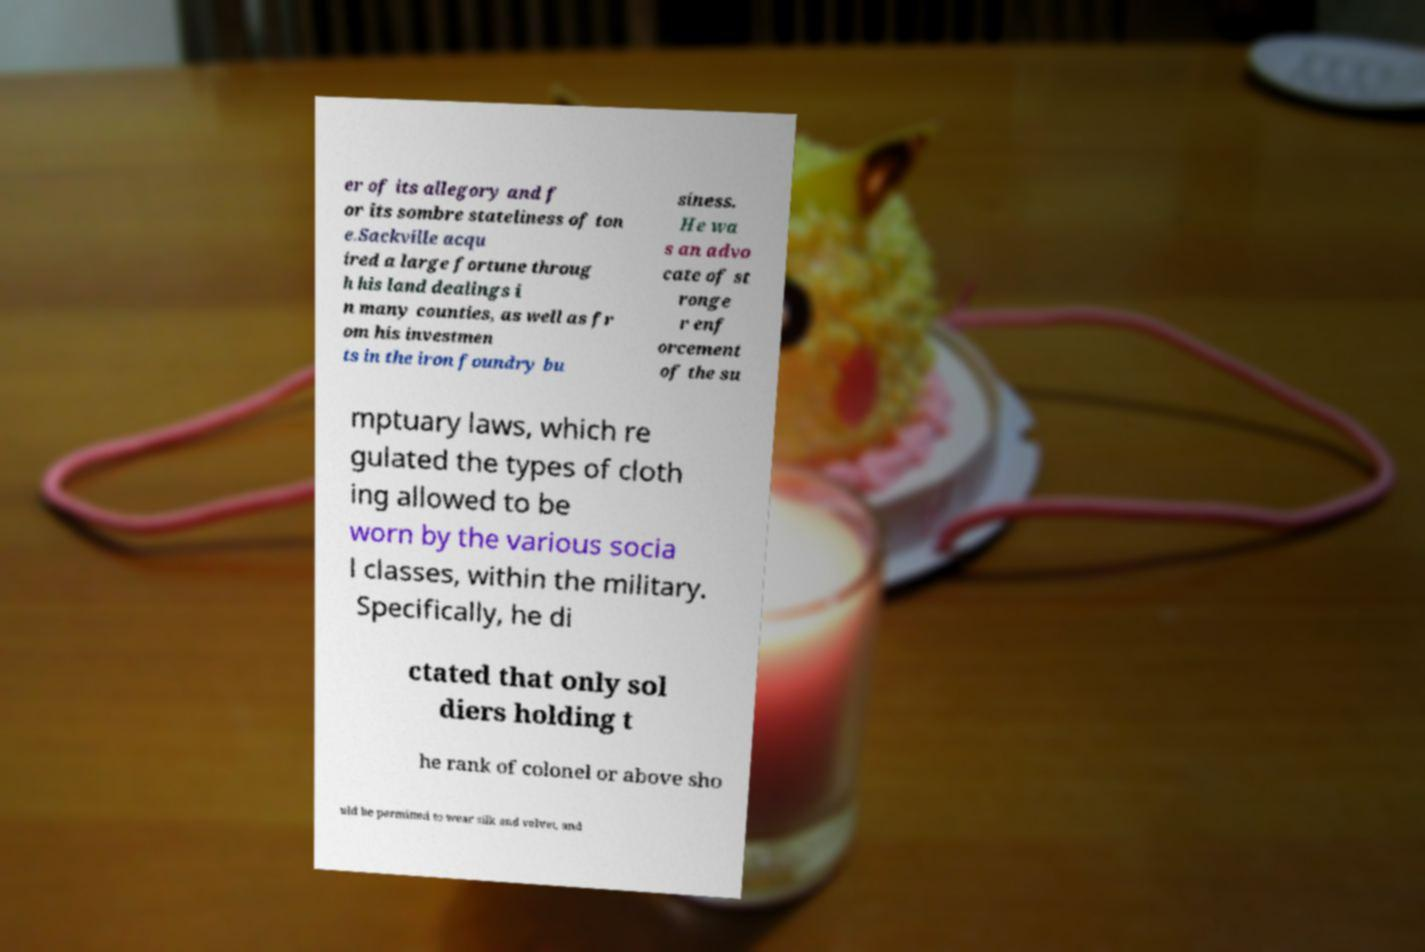What messages or text are displayed in this image? I need them in a readable, typed format. er of its allegory and f or its sombre stateliness of ton e.Sackville acqu ired a large fortune throug h his land dealings i n many counties, as well as fr om his investmen ts in the iron foundry bu siness. He wa s an advo cate of st ronge r enf orcement of the su mptuary laws, which re gulated the types of cloth ing allowed to be worn by the various socia l classes, within the military. Specifically, he di ctated that only sol diers holding t he rank of colonel or above sho uld be permitted to wear silk and velvet, and 